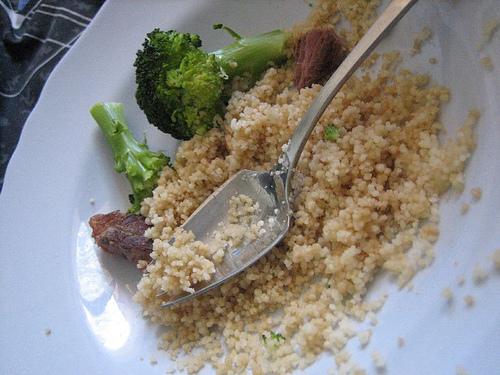What utensil is pictured?
Be succinct. Spoon. What sort of rice is shown?
Be succinct. Brown. Does broccoli increase T levels?
Answer briefly. Yes. What was the person using to eat their meal?
Short answer required. Spoon. What silverware is sitting on the plate?
Short answer required. Spoon. How many utensils are pictured?
Short answer required. 1. Is the spoon sterling silver?
Write a very short answer. Yes. What vegetable is shown?
Give a very brief answer. Broccoli. 